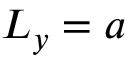Convert formula to latex. <formula><loc_0><loc_0><loc_500><loc_500>L _ { y } = a</formula> 